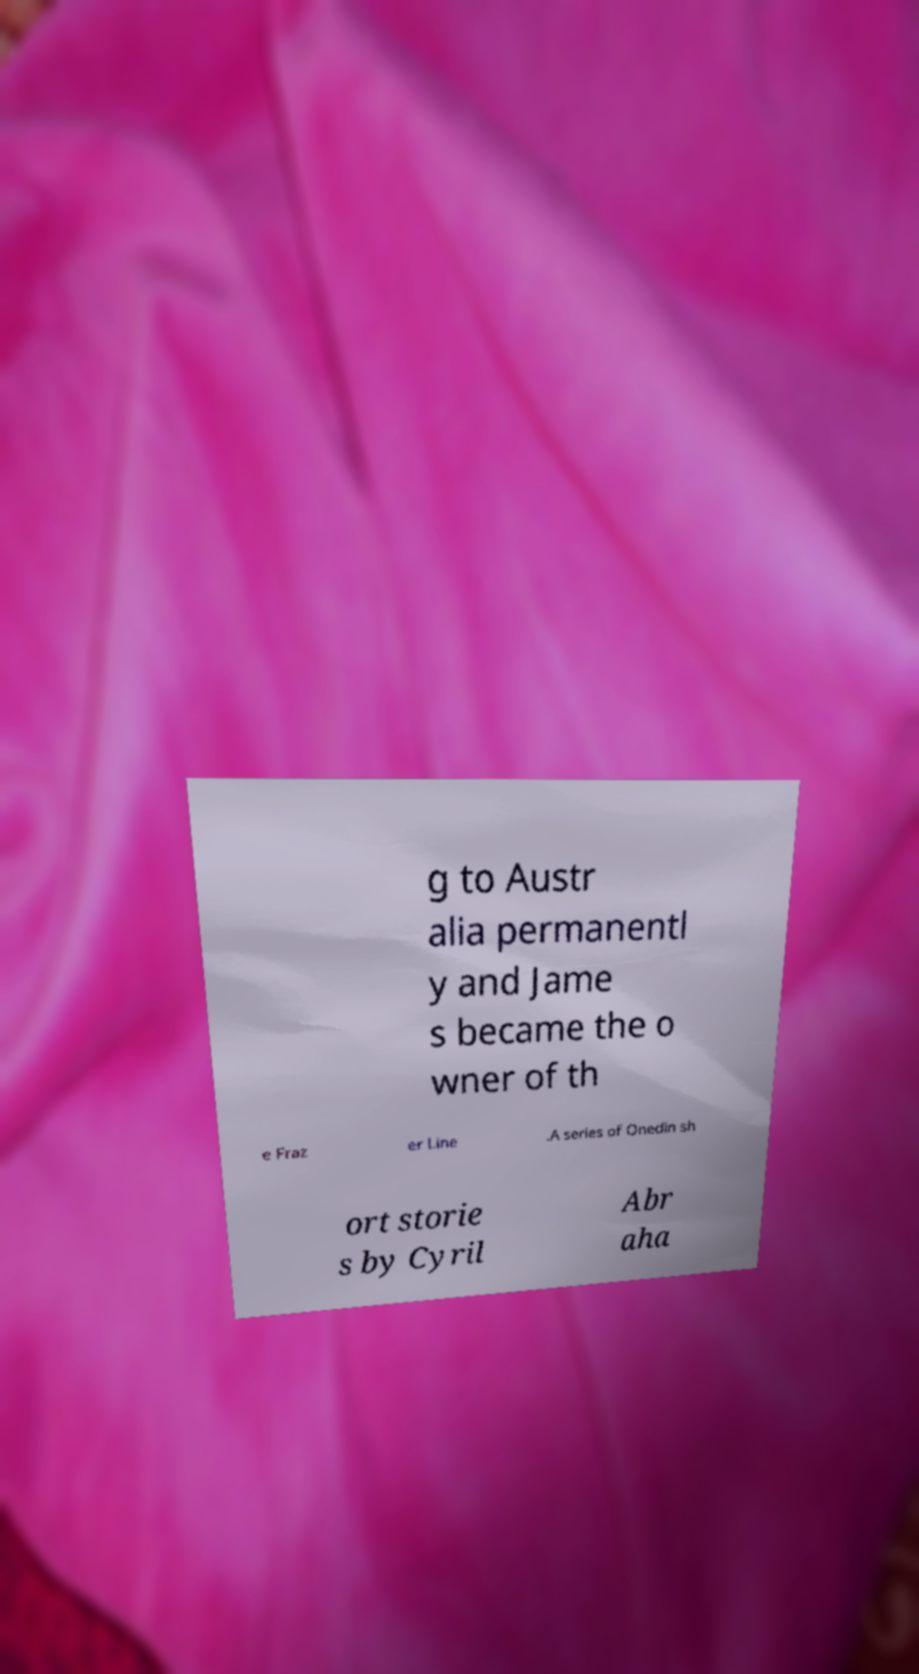Could you assist in decoding the text presented in this image and type it out clearly? g to Austr alia permanentl y and Jame s became the o wner of th e Fraz er Line .A series of Onedin sh ort storie s by Cyril Abr aha 